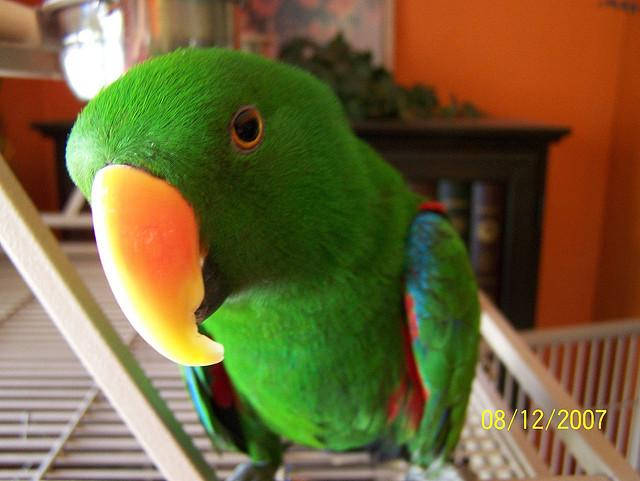Which bird can grind their own calcium supplements? Please explain your reasoning. parrot. There is a bright colored bird in the picture. 